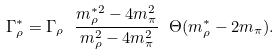<formula> <loc_0><loc_0><loc_500><loc_500>\Gamma ^ { * } _ { \rho } = \Gamma _ { \rho } \ \frac { m ^ { * 2 } _ { \rho } - 4 m _ { \pi } ^ { 2 } } { m ^ { 2 } _ { \rho } - 4 m _ { \pi } ^ { 2 } } \ \Theta ( m ^ { * } _ { \rho } - 2 m _ { \pi } ) .</formula> 